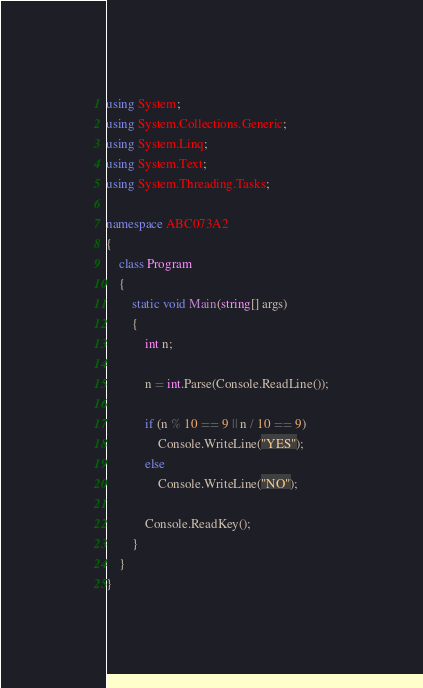<code> <loc_0><loc_0><loc_500><loc_500><_C#_>using System;
using System.Collections.Generic;
using System.Linq;
using System.Text;
using System.Threading.Tasks;

namespace ABC073A2
{
    class Program
    {
        static void Main(string[] args)
        {
            int n;

            n = int.Parse(Console.ReadLine());

            if (n % 10 == 9 || n / 10 == 9)
                Console.WriteLine("YES");
            else
                Console.WriteLine("NO");

            Console.ReadKey();
        }
    }
}
</code> 